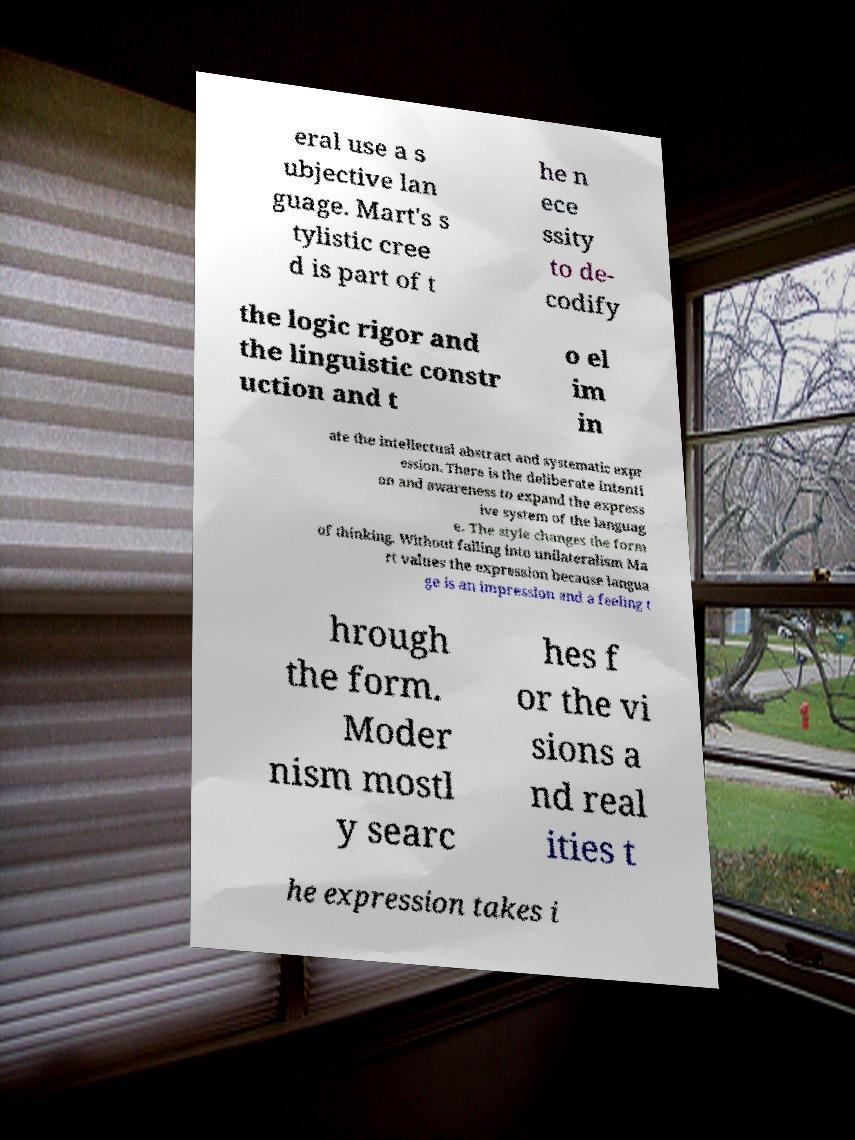Please identify and transcribe the text found in this image. eral use a s ubjective lan guage. Mart's s tylistic cree d is part of t he n ece ssity to de- codify the logic rigor and the linguistic constr uction and t o el im in ate the intellectual abstract and systematic expr ession. There is the deliberate intenti on and awareness to expand the express ive system of the languag e. The style changes the form of thinking. Without falling into unilateralism Ma rt values the expression because langua ge is an impression and a feeling t hrough the form. Moder nism mostl y searc hes f or the vi sions a nd real ities t he expression takes i 